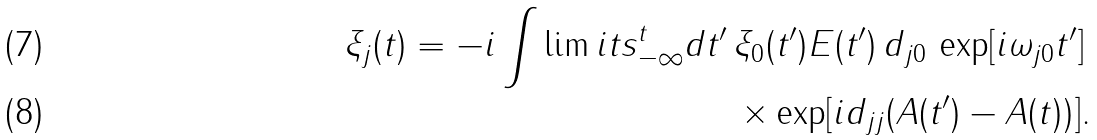Convert formula to latex. <formula><loc_0><loc_0><loc_500><loc_500>\xi _ { j } ( t ) = - i \int \lim i t s _ { - \infty } ^ { t } d t ^ { \prime } \, \xi _ { 0 } ( t ^ { \prime } ) E ( t ^ { \prime } ) \, d _ { j 0 } \, \exp [ i \omega _ { j 0 } t ^ { \prime } ] \, \\ \times \exp [ i d _ { j j } ( A ( t ^ { \prime } ) - A ( t ) ) ] .</formula> 